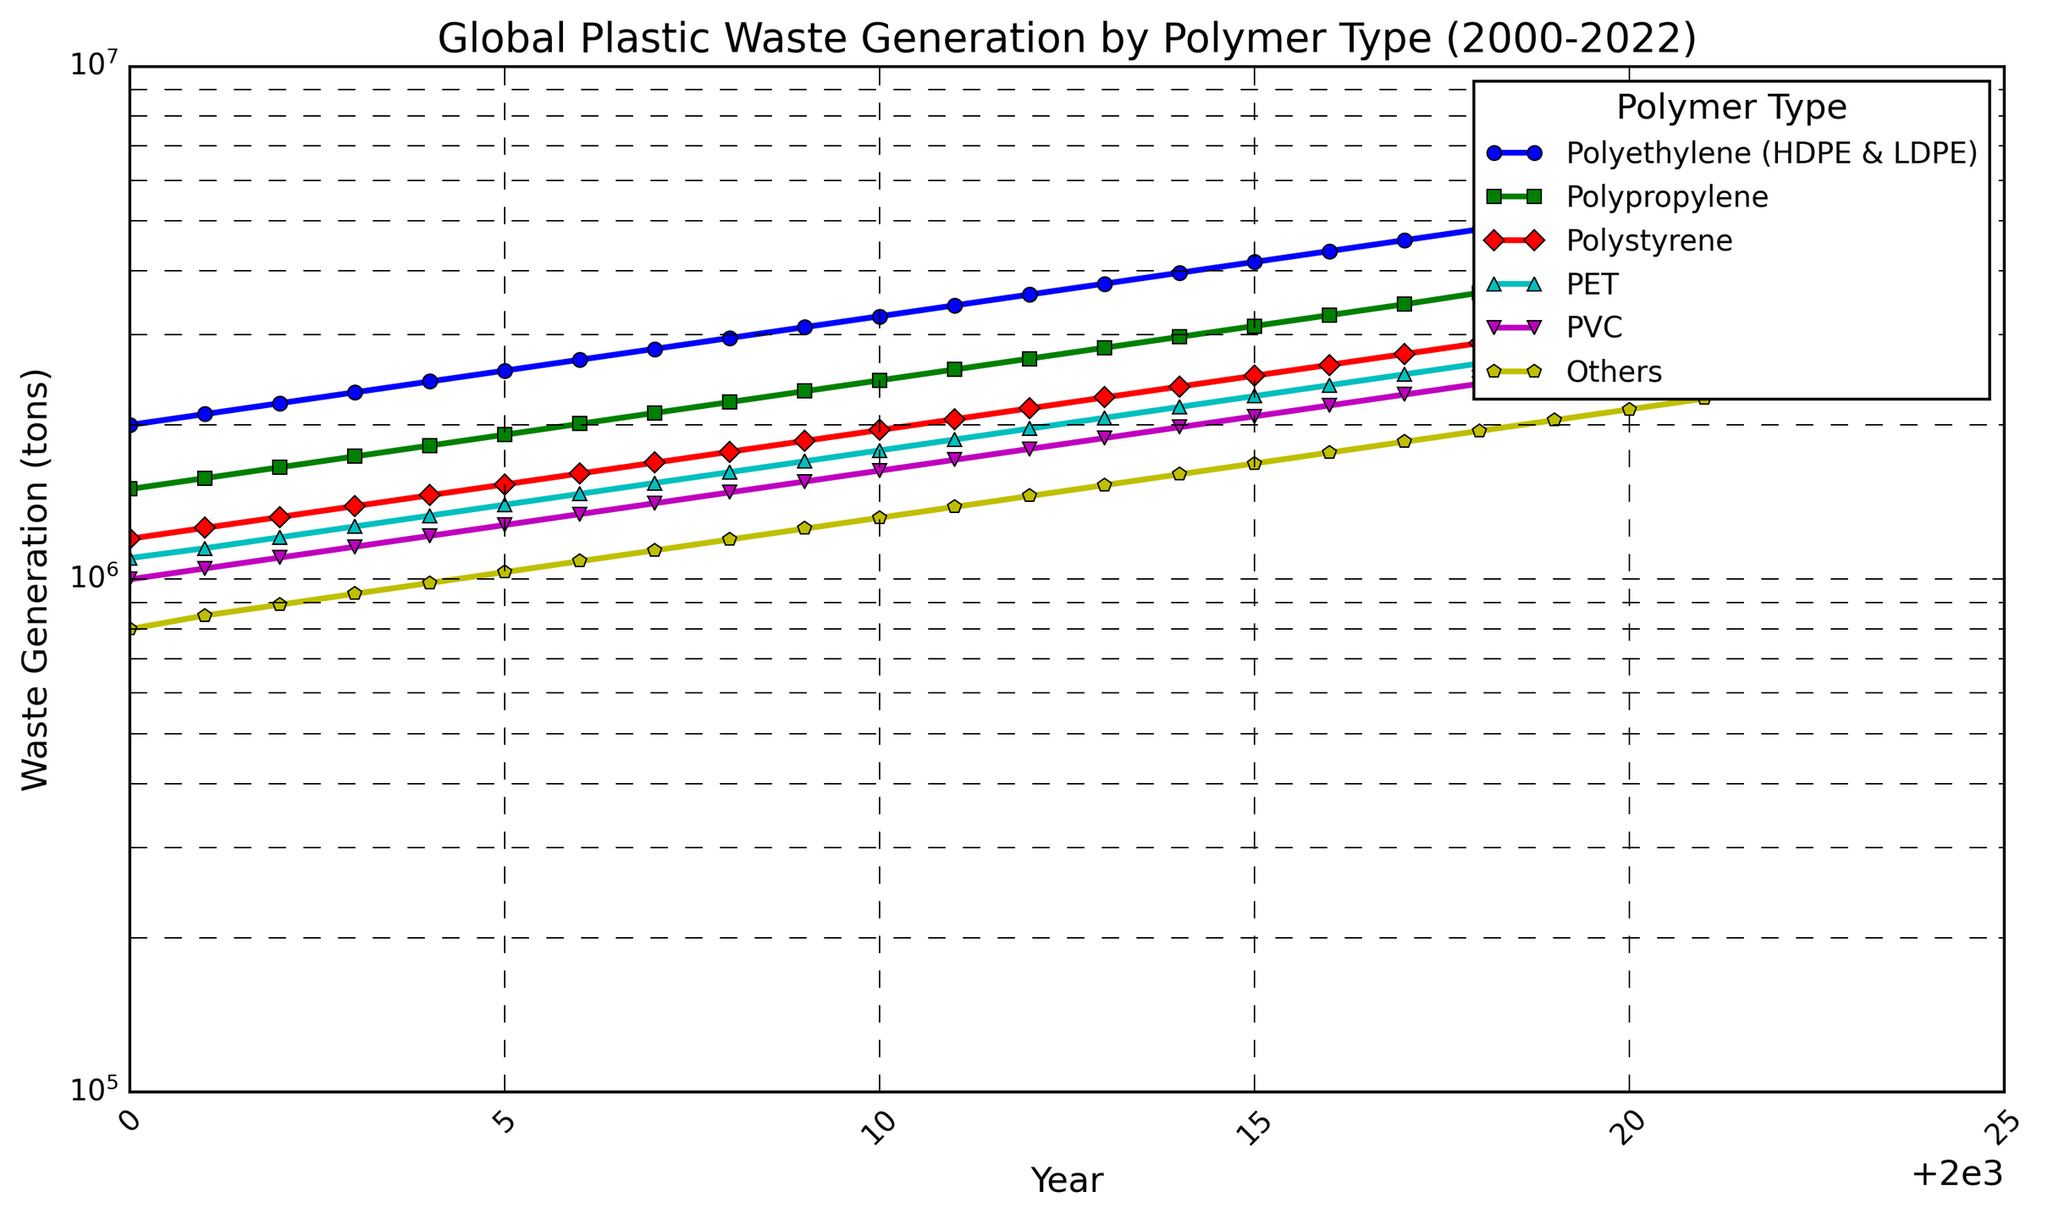what's the trend of global plastic waste generation for Polypropylene? The trend for Polypropylene can be seen by tracking the green line with square markers. From the year 2000 to 2022, the amount of Polypropylene waste generated increases steadily. In 2000, it starts at 1,500,000 tons and grows to 4,467,891 tons in 2022.
Answer: increasing steadily which polymer type had the highest waste generation in 2022? Look at the figure for the highest value in the year 2022. The blue line with circle markers representing Polyethylene (HDPE & LDPE) is at the top.
Answer: Polyethylene (HDPE & LDPE) how many polymer types exceeded 2 million tons of waste in 2010? Identify the lines on the plot in 2010. The lines above the 2 million tons mark (based on y-axis on log scale) are Polyethylene, Polypropylene, and PET. Hence, three polymer types exceeded 2 million tons.
Answer: 3 what's the difference in PVC waste generation between 2010 and 2020? The values for PVC in 2010 and 2020 are 1,628,894 and 2,653,300 tons respectively. Subtracting these two values gives 1,024,406 tons.
Answer: 1,024,406 tons compare the waste generation of Polystyrene and Others in 2005. Which one is higher? Compare the red and yellow lines for the year 2005. The waste generation for Polystyrene (~1,531,538 tons) is higher than Others (~1,033,030 tons).
Answer: Polystyrene is higher by what factor did the PET waste generation increase from 2000 to 2022? PET waste in 2000 is 1,100,000 tons and in 2022 it is 3,203,654 tons. The factor can be calculated by dividing 3,203,654 by 1,100,000, which gives approximately 2.91.
Answer: about 2.91 which polymer type shows the steepest increase in waste generation? The steepest increase can be identified by the steepest slope on the plot. The blue line for Polyethylene (HDPE & LDPE) shows the steepest increase among all the polymer types.
Answer: Polyethylene (HDPE & LDPE) between 2015 and 2020, how many polymer types had a steady increase in waste generation? Check each line from 2015 to 2020. All polymer types show a steady increase within this period.
Answer: 6 which polymer type had the smallest increase in waste generation from 2000 to 2022? Evaluate the lines to see the smallest vertical difference from start to end. The Others category (yellow line) had the smallest increase.
Answer: Others what is the average waste generation of Polyethylene and PET in 2012? The values for Polyethylene and PET in 2012 are 3,591,713 and 1,966,878 tons respectively. Average can be found by summing these values and dividing by 2: (3,591,713 + 1,966,878) / 2 = 2,779,295.5 tons.
Answer: 2,779,295.5 tons 